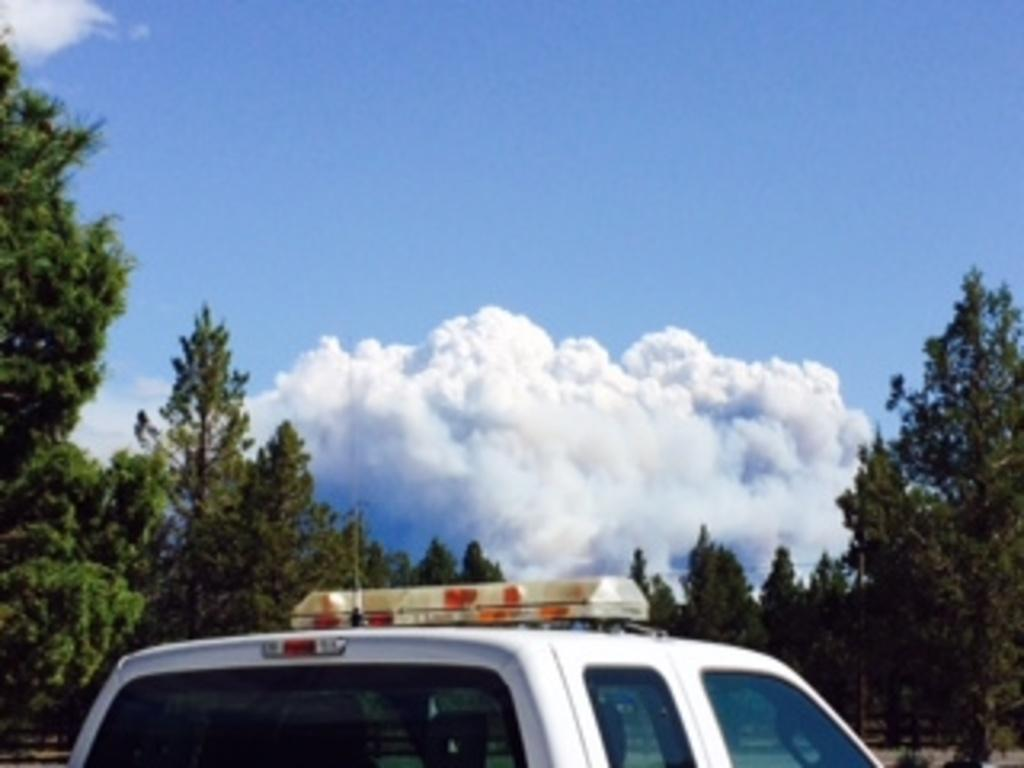What type of vehicle is in the image? There is a white color vehicle in the image. What can be seen in the background of the image? There are trees and the sky visible in the background of the image. What type of jewel is being served on a tray by the judge in the image? There is no jewel, tray, or judge present in the image. 